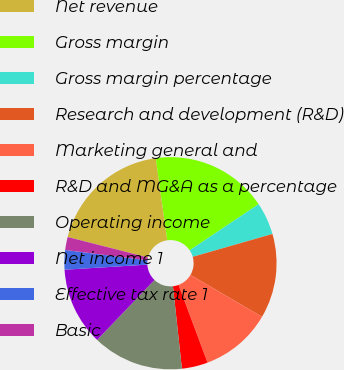Convert chart to OTSL. <chart><loc_0><loc_0><loc_500><loc_500><pie_chart><fcel>Net revenue<fcel>Gross margin<fcel>Gross margin percentage<fcel>Research and development (R&D)<fcel>Marketing general and<fcel>R&D and MG&A as a percentage<fcel>Operating income<fcel>Net income 1<fcel>Effective tax rate 1<fcel>Basic<nl><fcel>18.81%<fcel>17.82%<fcel>4.95%<fcel>12.87%<fcel>10.89%<fcel>3.96%<fcel>13.86%<fcel>11.88%<fcel>2.97%<fcel>1.98%<nl></chart> 